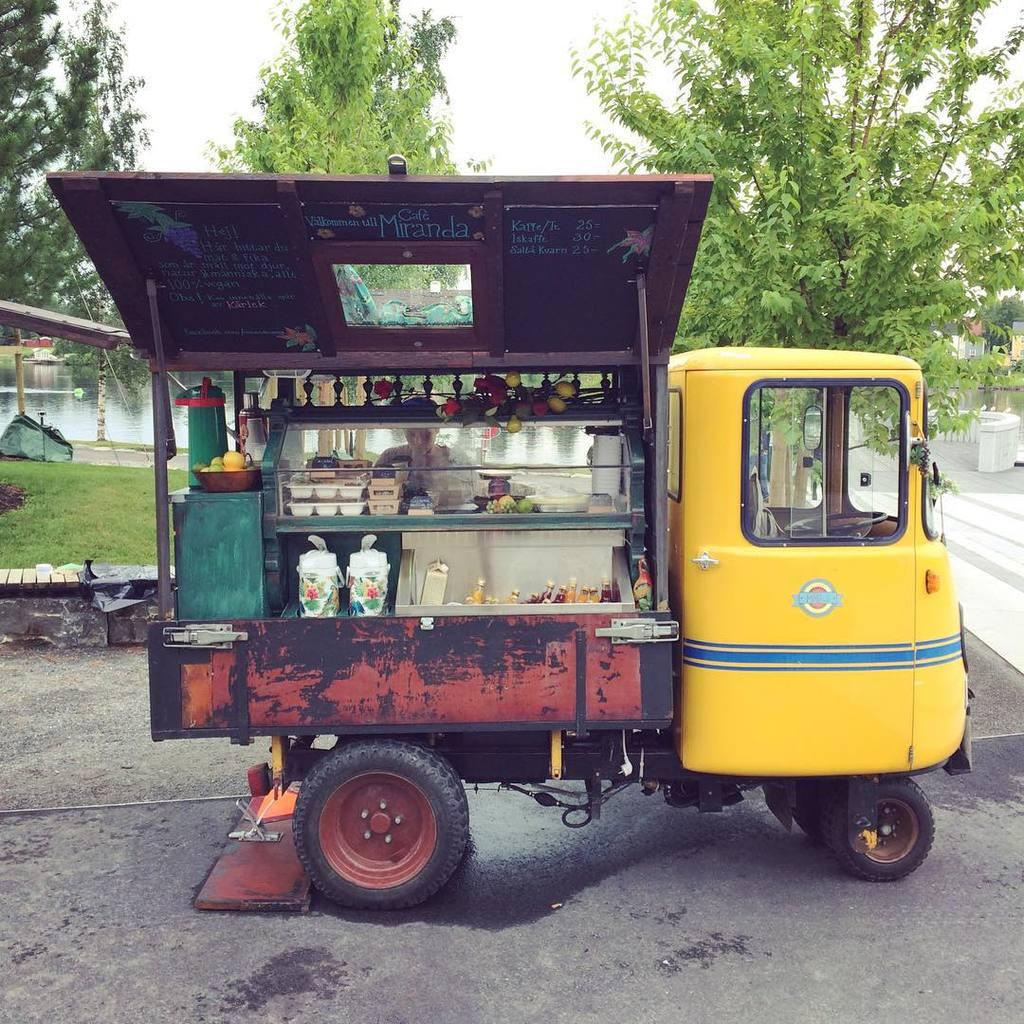What is the main subject in the image? There is a vehicle in the image. Can you describe the surface the vehicle is on? The vehicle is on a surface in the image. What type of vegetation can be seen in the image? There is green grass and trees in the image. What type of objects are present in the image besides the vehicle? There are plastic plates and plastic bottles in the image. How many apples are on the plastic plates in the image? There is no mention of apples in the image; only plastic plates and plastic bottles are present. 